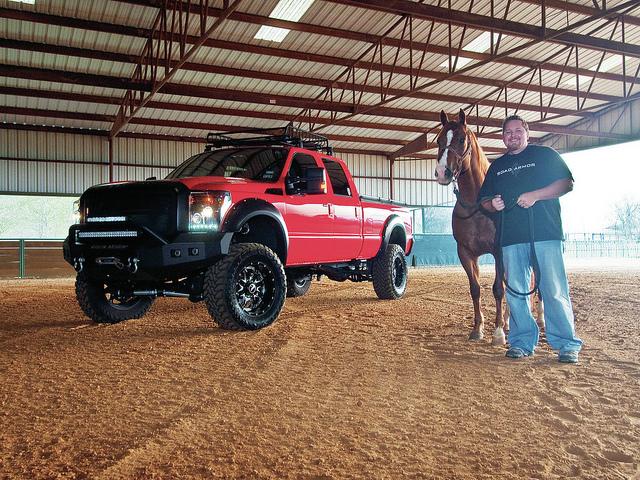Does the truck have a bra on?
Quick response, please. No. Is this a traditional barn?
Short answer required. No. Is there a horse next to the man?
Short answer required. Yes. 